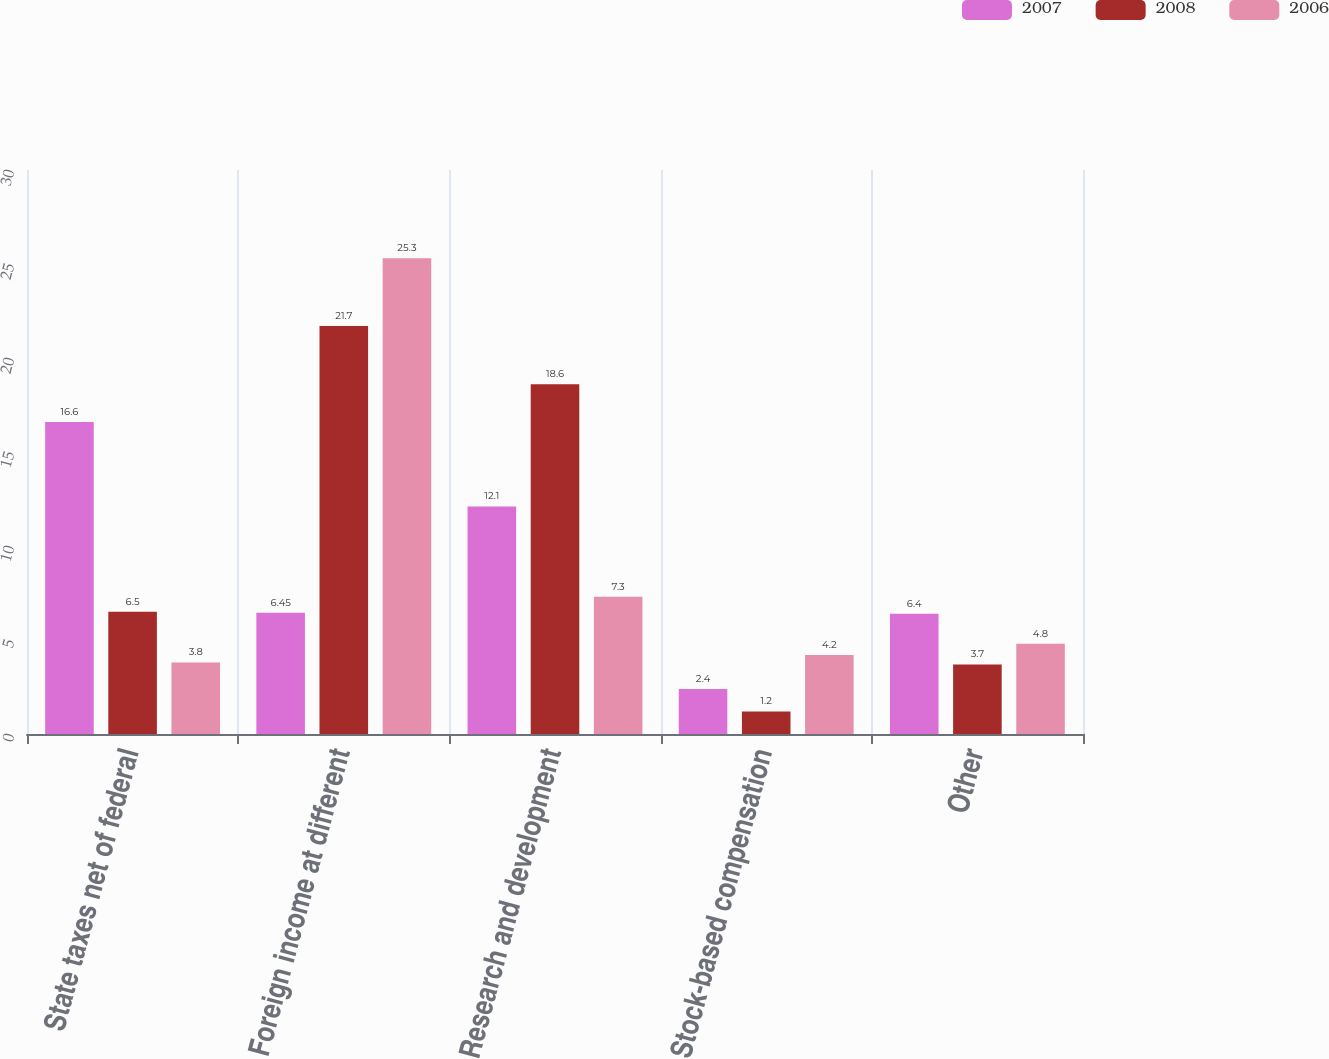Convert chart to OTSL. <chart><loc_0><loc_0><loc_500><loc_500><stacked_bar_chart><ecel><fcel>State taxes net of federal<fcel>Foreign income at different<fcel>Research and development<fcel>Stock-based compensation<fcel>Other<nl><fcel>2007<fcel>16.6<fcel>6.45<fcel>12.1<fcel>2.4<fcel>6.4<nl><fcel>2008<fcel>6.5<fcel>21.7<fcel>18.6<fcel>1.2<fcel>3.7<nl><fcel>2006<fcel>3.8<fcel>25.3<fcel>7.3<fcel>4.2<fcel>4.8<nl></chart> 